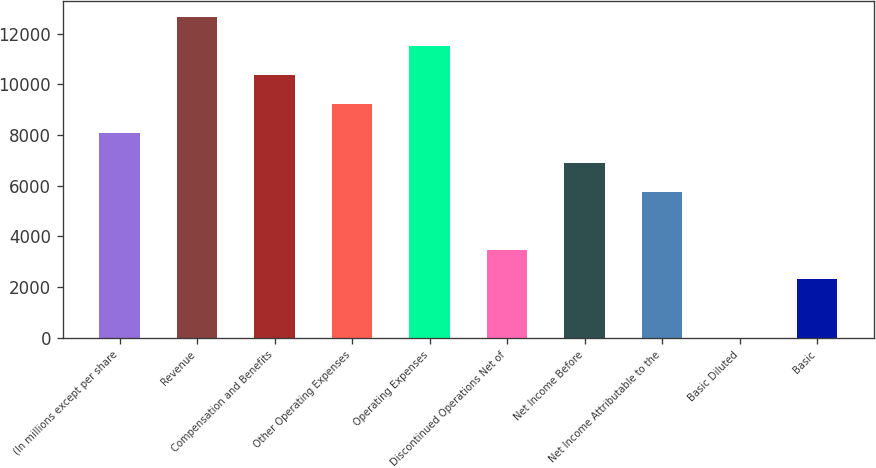<chart> <loc_0><loc_0><loc_500><loc_500><bar_chart><fcel>(In millions except per share<fcel>Revenue<fcel>Compensation and Benefits<fcel>Other Operating Expenses<fcel>Operating Expenses<fcel>Discontinued Operations Net of<fcel>Net Income Before<fcel>Net Income Attributable to the<fcel>Basic Diluted<fcel>Basic<nl><fcel>8068.74<fcel>12678.5<fcel>10373.6<fcel>9221.17<fcel>11526<fcel>3459.02<fcel>6916.31<fcel>5763.88<fcel>1.73<fcel>2306.59<nl></chart> 